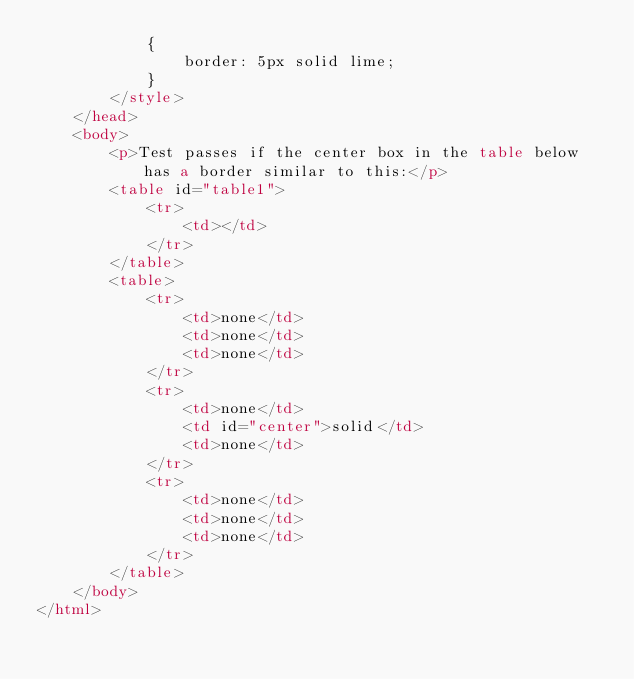Convert code to text. <code><loc_0><loc_0><loc_500><loc_500><_HTML_>            {
                border: 5px solid lime;
            }
        </style>
    </head>
    <body>
        <p>Test passes if the center box in the table below has a border similar to this:</p>
        <table id="table1">
            <tr>
                <td></td>
            </tr>
        </table>
        <table>
            <tr>
                <td>none</td>
                <td>none</td>
                <td>none</td>
            </tr>
            <tr>
                <td>none</td>
                <td id="center">solid</td>
                <td>none</td>
            </tr>
            <tr>
                <td>none</td>
                <td>none</td>
                <td>none</td>
            </tr>
        </table>
    </body>
</html></code> 